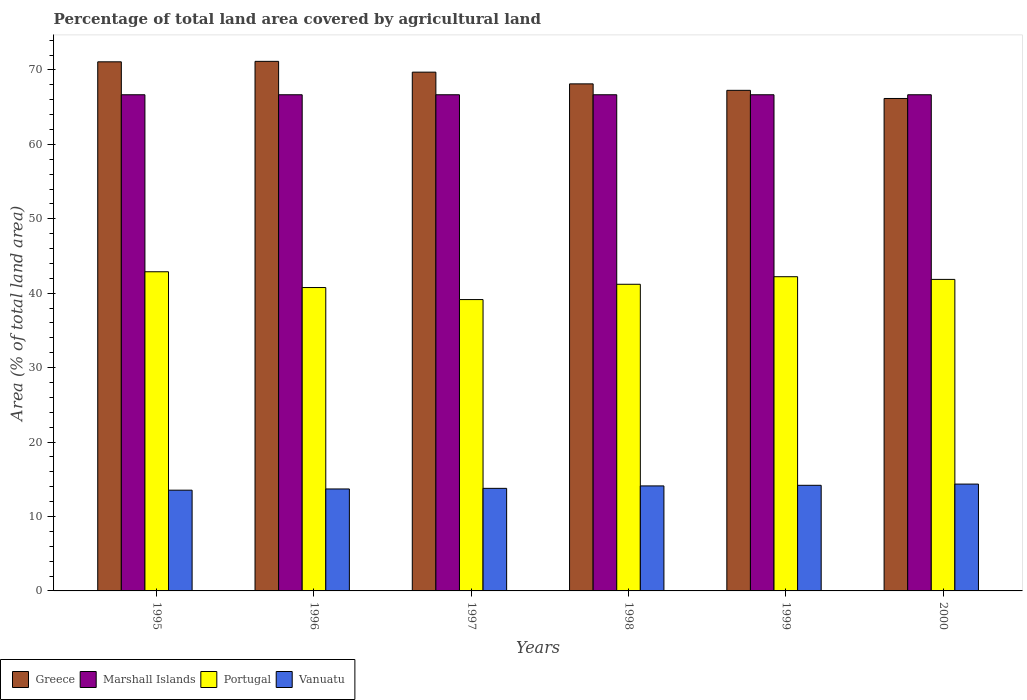Are the number of bars per tick equal to the number of legend labels?
Provide a short and direct response. Yes. Are the number of bars on each tick of the X-axis equal?
Offer a terse response. Yes. How many bars are there on the 3rd tick from the right?
Offer a terse response. 4. In how many cases, is the number of bars for a given year not equal to the number of legend labels?
Offer a very short reply. 0. What is the percentage of agricultural land in Vanuatu in 1998?
Offer a terse response. 14.11. Across all years, what is the maximum percentage of agricultural land in Vanuatu?
Give a very brief answer. 14.36. Across all years, what is the minimum percentage of agricultural land in Vanuatu?
Provide a succinct answer. 13.54. In which year was the percentage of agricultural land in Vanuatu maximum?
Your answer should be compact. 2000. In which year was the percentage of agricultural land in Portugal minimum?
Provide a succinct answer. 1997. What is the total percentage of agricultural land in Portugal in the graph?
Provide a short and direct response. 248.08. What is the difference between the percentage of agricultural land in Portugal in 1998 and that in 1999?
Provide a short and direct response. -1.02. What is the difference between the percentage of agricultural land in Vanuatu in 1998 and the percentage of agricultural land in Greece in 1995?
Provide a succinct answer. -56.98. What is the average percentage of agricultural land in Greece per year?
Keep it short and to the point. 68.92. In the year 1997, what is the difference between the percentage of agricultural land in Portugal and percentage of agricultural land in Vanuatu?
Provide a short and direct response. 25.37. What is the ratio of the percentage of agricultural land in Portugal in 1995 to that in 1997?
Offer a very short reply. 1.1. Is the difference between the percentage of agricultural land in Portugal in 1996 and 1999 greater than the difference between the percentage of agricultural land in Vanuatu in 1996 and 1999?
Ensure brevity in your answer.  No. What is the difference between the highest and the second highest percentage of agricultural land in Marshall Islands?
Your answer should be compact. 0. What is the difference between the highest and the lowest percentage of agricultural land in Marshall Islands?
Your response must be concise. 0. In how many years, is the percentage of agricultural land in Portugal greater than the average percentage of agricultural land in Portugal taken over all years?
Offer a terse response. 3. Is the sum of the percentage of agricultural land in Portugal in 1996 and 1999 greater than the maximum percentage of agricultural land in Vanuatu across all years?
Your answer should be very brief. Yes. What does the 3rd bar from the left in 1995 represents?
Keep it short and to the point. Portugal. What does the 3rd bar from the right in 1998 represents?
Provide a short and direct response. Marshall Islands. Are all the bars in the graph horizontal?
Offer a terse response. No. How many years are there in the graph?
Provide a succinct answer. 6. Are the values on the major ticks of Y-axis written in scientific E-notation?
Your response must be concise. No. Does the graph contain any zero values?
Your answer should be compact. No. Does the graph contain grids?
Give a very brief answer. No. Where does the legend appear in the graph?
Your response must be concise. Bottom left. How are the legend labels stacked?
Keep it short and to the point. Horizontal. What is the title of the graph?
Your response must be concise. Percentage of total land area covered by agricultural land. Does "Haiti" appear as one of the legend labels in the graph?
Provide a short and direct response. No. What is the label or title of the X-axis?
Ensure brevity in your answer.  Years. What is the label or title of the Y-axis?
Your answer should be very brief. Area (% of total land area). What is the Area (% of total land area) in Greece in 1995?
Offer a very short reply. 71.09. What is the Area (% of total land area) of Marshall Islands in 1995?
Keep it short and to the point. 66.67. What is the Area (% of total land area) of Portugal in 1995?
Give a very brief answer. 42.89. What is the Area (% of total land area) in Vanuatu in 1995?
Provide a succinct answer. 13.54. What is the Area (% of total land area) of Greece in 1996?
Make the answer very short. 71.16. What is the Area (% of total land area) of Marshall Islands in 1996?
Provide a short and direct response. 66.67. What is the Area (% of total land area) of Portugal in 1996?
Offer a terse response. 40.77. What is the Area (% of total land area) in Vanuatu in 1996?
Keep it short and to the point. 13.7. What is the Area (% of total land area) in Greece in 1997?
Your answer should be compact. 69.71. What is the Area (% of total land area) in Marshall Islands in 1997?
Provide a succinct answer. 66.67. What is the Area (% of total land area) of Portugal in 1997?
Make the answer very short. 39.15. What is the Area (% of total land area) in Vanuatu in 1997?
Provide a succinct answer. 13.78. What is the Area (% of total land area) of Greece in 1998?
Offer a terse response. 68.13. What is the Area (% of total land area) of Marshall Islands in 1998?
Make the answer very short. 66.67. What is the Area (% of total land area) in Portugal in 1998?
Your response must be concise. 41.2. What is the Area (% of total land area) in Vanuatu in 1998?
Offer a very short reply. 14.11. What is the Area (% of total land area) of Greece in 1999?
Make the answer very short. 67.26. What is the Area (% of total land area) in Marshall Islands in 1999?
Your response must be concise. 66.67. What is the Area (% of total land area) of Portugal in 1999?
Provide a short and direct response. 42.22. What is the Area (% of total land area) of Vanuatu in 1999?
Provide a short and direct response. 14.19. What is the Area (% of total land area) of Greece in 2000?
Your answer should be very brief. 66.17. What is the Area (% of total land area) of Marshall Islands in 2000?
Provide a short and direct response. 66.67. What is the Area (% of total land area) in Portugal in 2000?
Offer a very short reply. 41.86. What is the Area (% of total land area) in Vanuatu in 2000?
Offer a terse response. 14.36. Across all years, what is the maximum Area (% of total land area) of Greece?
Your answer should be compact. 71.16. Across all years, what is the maximum Area (% of total land area) of Marshall Islands?
Offer a terse response. 66.67. Across all years, what is the maximum Area (% of total land area) in Portugal?
Ensure brevity in your answer.  42.89. Across all years, what is the maximum Area (% of total land area) in Vanuatu?
Offer a very short reply. 14.36. Across all years, what is the minimum Area (% of total land area) of Greece?
Make the answer very short. 66.17. Across all years, what is the minimum Area (% of total land area) of Marshall Islands?
Offer a very short reply. 66.67. Across all years, what is the minimum Area (% of total land area) of Portugal?
Make the answer very short. 39.15. Across all years, what is the minimum Area (% of total land area) in Vanuatu?
Your answer should be compact. 13.54. What is the total Area (% of total land area) of Greece in the graph?
Your answer should be very brief. 413.51. What is the total Area (% of total land area) of Portugal in the graph?
Offer a terse response. 248.08. What is the total Area (% of total land area) of Vanuatu in the graph?
Provide a short and direct response. 83.68. What is the difference between the Area (% of total land area) of Greece in 1995 and that in 1996?
Ensure brevity in your answer.  -0.06. What is the difference between the Area (% of total land area) in Marshall Islands in 1995 and that in 1996?
Give a very brief answer. 0. What is the difference between the Area (% of total land area) of Portugal in 1995 and that in 1996?
Give a very brief answer. 2.12. What is the difference between the Area (% of total land area) of Vanuatu in 1995 and that in 1996?
Provide a short and direct response. -0.16. What is the difference between the Area (% of total land area) of Greece in 1995 and that in 1997?
Give a very brief answer. 1.39. What is the difference between the Area (% of total land area) in Portugal in 1995 and that in 1997?
Offer a terse response. 3.74. What is the difference between the Area (% of total land area) in Vanuatu in 1995 and that in 1997?
Keep it short and to the point. -0.25. What is the difference between the Area (% of total land area) of Greece in 1995 and that in 1998?
Your answer should be compact. 2.96. What is the difference between the Area (% of total land area) of Portugal in 1995 and that in 1998?
Offer a very short reply. 1.68. What is the difference between the Area (% of total land area) of Vanuatu in 1995 and that in 1998?
Make the answer very short. -0.57. What is the difference between the Area (% of total land area) in Greece in 1995 and that in 1999?
Provide a short and direct response. 3.83. What is the difference between the Area (% of total land area) in Vanuatu in 1995 and that in 1999?
Give a very brief answer. -0.66. What is the difference between the Area (% of total land area) of Greece in 1995 and that in 2000?
Ensure brevity in your answer.  4.93. What is the difference between the Area (% of total land area) in Portugal in 1995 and that in 2000?
Keep it short and to the point. 1.03. What is the difference between the Area (% of total land area) in Vanuatu in 1995 and that in 2000?
Ensure brevity in your answer.  -0.82. What is the difference between the Area (% of total land area) of Greece in 1996 and that in 1997?
Offer a very short reply. 1.45. What is the difference between the Area (% of total land area) in Portugal in 1996 and that in 1997?
Give a very brief answer. 1.62. What is the difference between the Area (% of total land area) in Vanuatu in 1996 and that in 1997?
Ensure brevity in your answer.  -0.08. What is the difference between the Area (% of total land area) in Greece in 1996 and that in 1998?
Offer a terse response. 3.03. What is the difference between the Area (% of total land area) in Marshall Islands in 1996 and that in 1998?
Offer a terse response. 0. What is the difference between the Area (% of total land area) in Portugal in 1996 and that in 1998?
Your answer should be very brief. -0.44. What is the difference between the Area (% of total land area) in Vanuatu in 1996 and that in 1998?
Offer a very short reply. -0.41. What is the difference between the Area (% of total land area) in Greece in 1996 and that in 1999?
Offer a very short reply. 3.89. What is the difference between the Area (% of total land area) of Marshall Islands in 1996 and that in 1999?
Your answer should be very brief. 0. What is the difference between the Area (% of total land area) in Portugal in 1996 and that in 1999?
Offer a very short reply. -1.45. What is the difference between the Area (% of total land area) of Vanuatu in 1996 and that in 1999?
Provide a succinct answer. -0.49. What is the difference between the Area (% of total land area) in Greece in 1996 and that in 2000?
Provide a succinct answer. 4.99. What is the difference between the Area (% of total land area) of Marshall Islands in 1996 and that in 2000?
Your answer should be very brief. 0. What is the difference between the Area (% of total land area) in Portugal in 1996 and that in 2000?
Provide a succinct answer. -1.09. What is the difference between the Area (% of total land area) of Vanuatu in 1996 and that in 2000?
Provide a succinct answer. -0.66. What is the difference between the Area (% of total land area) in Greece in 1997 and that in 1998?
Provide a succinct answer. 1.57. What is the difference between the Area (% of total land area) in Portugal in 1997 and that in 1998?
Your answer should be compact. -2.05. What is the difference between the Area (% of total land area) of Vanuatu in 1997 and that in 1998?
Ensure brevity in your answer.  -0.33. What is the difference between the Area (% of total land area) of Greece in 1997 and that in 1999?
Provide a short and direct response. 2.44. What is the difference between the Area (% of total land area) in Marshall Islands in 1997 and that in 1999?
Your answer should be compact. 0. What is the difference between the Area (% of total land area) of Portugal in 1997 and that in 1999?
Your answer should be compact. -3.07. What is the difference between the Area (% of total land area) of Vanuatu in 1997 and that in 1999?
Offer a terse response. -0.41. What is the difference between the Area (% of total land area) in Greece in 1997 and that in 2000?
Give a very brief answer. 3.54. What is the difference between the Area (% of total land area) of Portugal in 1997 and that in 2000?
Provide a succinct answer. -2.71. What is the difference between the Area (% of total land area) in Vanuatu in 1997 and that in 2000?
Your answer should be very brief. -0.57. What is the difference between the Area (% of total land area) of Greece in 1998 and that in 1999?
Make the answer very short. 0.87. What is the difference between the Area (% of total land area) in Portugal in 1998 and that in 1999?
Ensure brevity in your answer.  -1.02. What is the difference between the Area (% of total land area) in Vanuatu in 1998 and that in 1999?
Offer a terse response. -0.08. What is the difference between the Area (% of total land area) of Greece in 1998 and that in 2000?
Ensure brevity in your answer.  1.96. What is the difference between the Area (% of total land area) of Portugal in 1998 and that in 2000?
Offer a very short reply. -0.66. What is the difference between the Area (% of total land area) of Vanuatu in 1998 and that in 2000?
Ensure brevity in your answer.  -0.25. What is the difference between the Area (% of total land area) of Greece in 1999 and that in 2000?
Ensure brevity in your answer.  1.09. What is the difference between the Area (% of total land area) of Portugal in 1999 and that in 2000?
Your answer should be very brief. 0.36. What is the difference between the Area (% of total land area) in Vanuatu in 1999 and that in 2000?
Your answer should be compact. -0.16. What is the difference between the Area (% of total land area) of Greece in 1995 and the Area (% of total land area) of Marshall Islands in 1996?
Offer a terse response. 4.43. What is the difference between the Area (% of total land area) of Greece in 1995 and the Area (% of total land area) of Portugal in 1996?
Make the answer very short. 30.33. What is the difference between the Area (% of total land area) of Greece in 1995 and the Area (% of total land area) of Vanuatu in 1996?
Your answer should be compact. 57.39. What is the difference between the Area (% of total land area) of Marshall Islands in 1995 and the Area (% of total land area) of Portugal in 1996?
Ensure brevity in your answer.  25.9. What is the difference between the Area (% of total land area) of Marshall Islands in 1995 and the Area (% of total land area) of Vanuatu in 1996?
Keep it short and to the point. 52.97. What is the difference between the Area (% of total land area) of Portugal in 1995 and the Area (% of total land area) of Vanuatu in 1996?
Keep it short and to the point. 29.19. What is the difference between the Area (% of total land area) of Greece in 1995 and the Area (% of total land area) of Marshall Islands in 1997?
Offer a very short reply. 4.43. What is the difference between the Area (% of total land area) of Greece in 1995 and the Area (% of total land area) of Portugal in 1997?
Keep it short and to the point. 31.95. What is the difference between the Area (% of total land area) of Greece in 1995 and the Area (% of total land area) of Vanuatu in 1997?
Offer a very short reply. 57.31. What is the difference between the Area (% of total land area) in Marshall Islands in 1995 and the Area (% of total land area) in Portugal in 1997?
Provide a short and direct response. 27.52. What is the difference between the Area (% of total land area) of Marshall Islands in 1995 and the Area (% of total land area) of Vanuatu in 1997?
Provide a succinct answer. 52.88. What is the difference between the Area (% of total land area) of Portugal in 1995 and the Area (% of total land area) of Vanuatu in 1997?
Provide a short and direct response. 29.1. What is the difference between the Area (% of total land area) of Greece in 1995 and the Area (% of total land area) of Marshall Islands in 1998?
Provide a short and direct response. 4.43. What is the difference between the Area (% of total land area) of Greece in 1995 and the Area (% of total land area) of Portugal in 1998?
Offer a very short reply. 29.89. What is the difference between the Area (% of total land area) of Greece in 1995 and the Area (% of total land area) of Vanuatu in 1998?
Offer a terse response. 56.98. What is the difference between the Area (% of total land area) in Marshall Islands in 1995 and the Area (% of total land area) in Portugal in 1998?
Keep it short and to the point. 25.46. What is the difference between the Area (% of total land area) of Marshall Islands in 1995 and the Area (% of total land area) of Vanuatu in 1998?
Keep it short and to the point. 52.56. What is the difference between the Area (% of total land area) in Portugal in 1995 and the Area (% of total land area) in Vanuatu in 1998?
Your answer should be compact. 28.78. What is the difference between the Area (% of total land area) of Greece in 1995 and the Area (% of total land area) of Marshall Islands in 1999?
Ensure brevity in your answer.  4.43. What is the difference between the Area (% of total land area) in Greece in 1995 and the Area (% of total land area) in Portugal in 1999?
Provide a short and direct response. 28.88. What is the difference between the Area (% of total land area) of Greece in 1995 and the Area (% of total land area) of Vanuatu in 1999?
Your response must be concise. 56.9. What is the difference between the Area (% of total land area) of Marshall Islands in 1995 and the Area (% of total land area) of Portugal in 1999?
Ensure brevity in your answer.  24.45. What is the difference between the Area (% of total land area) of Marshall Islands in 1995 and the Area (% of total land area) of Vanuatu in 1999?
Keep it short and to the point. 52.47. What is the difference between the Area (% of total land area) in Portugal in 1995 and the Area (% of total land area) in Vanuatu in 1999?
Offer a very short reply. 28.69. What is the difference between the Area (% of total land area) of Greece in 1995 and the Area (% of total land area) of Marshall Islands in 2000?
Your answer should be compact. 4.43. What is the difference between the Area (% of total land area) in Greece in 1995 and the Area (% of total land area) in Portugal in 2000?
Offer a very short reply. 29.24. What is the difference between the Area (% of total land area) of Greece in 1995 and the Area (% of total land area) of Vanuatu in 2000?
Your answer should be very brief. 56.74. What is the difference between the Area (% of total land area) in Marshall Islands in 1995 and the Area (% of total land area) in Portugal in 2000?
Ensure brevity in your answer.  24.81. What is the difference between the Area (% of total land area) in Marshall Islands in 1995 and the Area (% of total land area) in Vanuatu in 2000?
Keep it short and to the point. 52.31. What is the difference between the Area (% of total land area) of Portugal in 1995 and the Area (% of total land area) of Vanuatu in 2000?
Ensure brevity in your answer.  28.53. What is the difference between the Area (% of total land area) in Greece in 1996 and the Area (% of total land area) in Marshall Islands in 1997?
Offer a very short reply. 4.49. What is the difference between the Area (% of total land area) in Greece in 1996 and the Area (% of total land area) in Portugal in 1997?
Offer a terse response. 32.01. What is the difference between the Area (% of total land area) in Greece in 1996 and the Area (% of total land area) in Vanuatu in 1997?
Ensure brevity in your answer.  57.37. What is the difference between the Area (% of total land area) of Marshall Islands in 1996 and the Area (% of total land area) of Portugal in 1997?
Your response must be concise. 27.52. What is the difference between the Area (% of total land area) of Marshall Islands in 1996 and the Area (% of total land area) of Vanuatu in 1997?
Keep it short and to the point. 52.88. What is the difference between the Area (% of total land area) of Portugal in 1996 and the Area (% of total land area) of Vanuatu in 1997?
Keep it short and to the point. 26.98. What is the difference between the Area (% of total land area) in Greece in 1996 and the Area (% of total land area) in Marshall Islands in 1998?
Make the answer very short. 4.49. What is the difference between the Area (% of total land area) in Greece in 1996 and the Area (% of total land area) in Portugal in 1998?
Give a very brief answer. 29.95. What is the difference between the Area (% of total land area) of Greece in 1996 and the Area (% of total land area) of Vanuatu in 1998?
Ensure brevity in your answer.  57.05. What is the difference between the Area (% of total land area) in Marshall Islands in 1996 and the Area (% of total land area) in Portugal in 1998?
Give a very brief answer. 25.46. What is the difference between the Area (% of total land area) of Marshall Islands in 1996 and the Area (% of total land area) of Vanuatu in 1998?
Offer a terse response. 52.56. What is the difference between the Area (% of total land area) in Portugal in 1996 and the Area (% of total land area) in Vanuatu in 1998?
Offer a terse response. 26.66. What is the difference between the Area (% of total land area) of Greece in 1996 and the Area (% of total land area) of Marshall Islands in 1999?
Offer a terse response. 4.49. What is the difference between the Area (% of total land area) of Greece in 1996 and the Area (% of total land area) of Portugal in 1999?
Your answer should be very brief. 28.94. What is the difference between the Area (% of total land area) in Greece in 1996 and the Area (% of total land area) in Vanuatu in 1999?
Ensure brevity in your answer.  56.96. What is the difference between the Area (% of total land area) in Marshall Islands in 1996 and the Area (% of total land area) in Portugal in 1999?
Make the answer very short. 24.45. What is the difference between the Area (% of total land area) of Marshall Islands in 1996 and the Area (% of total land area) of Vanuatu in 1999?
Your answer should be compact. 52.47. What is the difference between the Area (% of total land area) in Portugal in 1996 and the Area (% of total land area) in Vanuatu in 1999?
Offer a terse response. 26.57. What is the difference between the Area (% of total land area) of Greece in 1996 and the Area (% of total land area) of Marshall Islands in 2000?
Your response must be concise. 4.49. What is the difference between the Area (% of total land area) of Greece in 1996 and the Area (% of total land area) of Portugal in 2000?
Your response must be concise. 29.3. What is the difference between the Area (% of total land area) in Greece in 1996 and the Area (% of total land area) in Vanuatu in 2000?
Make the answer very short. 56.8. What is the difference between the Area (% of total land area) in Marshall Islands in 1996 and the Area (% of total land area) in Portugal in 2000?
Offer a terse response. 24.81. What is the difference between the Area (% of total land area) of Marshall Islands in 1996 and the Area (% of total land area) of Vanuatu in 2000?
Keep it short and to the point. 52.31. What is the difference between the Area (% of total land area) in Portugal in 1996 and the Area (% of total land area) in Vanuatu in 2000?
Ensure brevity in your answer.  26.41. What is the difference between the Area (% of total land area) in Greece in 1997 and the Area (% of total land area) in Marshall Islands in 1998?
Offer a terse response. 3.04. What is the difference between the Area (% of total land area) of Greece in 1997 and the Area (% of total land area) of Portugal in 1998?
Offer a terse response. 28.5. What is the difference between the Area (% of total land area) of Greece in 1997 and the Area (% of total land area) of Vanuatu in 1998?
Make the answer very short. 55.6. What is the difference between the Area (% of total land area) of Marshall Islands in 1997 and the Area (% of total land area) of Portugal in 1998?
Make the answer very short. 25.46. What is the difference between the Area (% of total land area) of Marshall Islands in 1997 and the Area (% of total land area) of Vanuatu in 1998?
Offer a terse response. 52.56. What is the difference between the Area (% of total land area) in Portugal in 1997 and the Area (% of total land area) in Vanuatu in 1998?
Your response must be concise. 25.04. What is the difference between the Area (% of total land area) in Greece in 1997 and the Area (% of total land area) in Marshall Islands in 1999?
Offer a very short reply. 3.04. What is the difference between the Area (% of total land area) in Greece in 1997 and the Area (% of total land area) in Portugal in 1999?
Offer a very short reply. 27.49. What is the difference between the Area (% of total land area) of Greece in 1997 and the Area (% of total land area) of Vanuatu in 1999?
Offer a terse response. 55.51. What is the difference between the Area (% of total land area) of Marshall Islands in 1997 and the Area (% of total land area) of Portugal in 1999?
Ensure brevity in your answer.  24.45. What is the difference between the Area (% of total land area) in Marshall Islands in 1997 and the Area (% of total land area) in Vanuatu in 1999?
Make the answer very short. 52.47. What is the difference between the Area (% of total land area) in Portugal in 1997 and the Area (% of total land area) in Vanuatu in 1999?
Give a very brief answer. 24.96. What is the difference between the Area (% of total land area) in Greece in 1997 and the Area (% of total land area) in Marshall Islands in 2000?
Ensure brevity in your answer.  3.04. What is the difference between the Area (% of total land area) of Greece in 1997 and the Area (% of total land area) of Portugal in 2000?
Your answer should be very brief. 27.85. What is the difference between the Area (% of total land area) in Greece in 1997 and the Area (% of total land area) in Vanuatu in 2000?
Offer a very short reply. 55.35. What is the difference between the Area (% of total land area) of Marshall Islands in 1997 and the Area (% of total land area) of Portugal in 2000?
Offer a very short reply. 24.81. What is the difference between the Area (% of total land area) in Marshall Islands in 1997 and the Area (% of total land area) in Vanuatu in 2000?
Offer a very short reply. 52.31. What is the difference between the Area (% of total land area) in Portugal in 1997 and the Area (% of total land area) in Vanuatu in 2000?
Offer a very short reply. 24.79. What is the difference between the Area (% of total land area) of Greece in 1998 and the Area (% of total land area) of Marshall Islands in 1999?
Your answer should be compact. 1.46. What is the difference between the Area (% of total land area) in Greece in 1998 and the Area (% of total land area) in Portugal in 1999?
Provide a short and direct response. 25.91. What is the difference between the Area (% of total land area) in Greece in 1998 and the Area (% of total land area) in Vanuatu in 1999?
Your answer should be very brief. 53.94. What is the difference between the Area (% of total land area) in Marshall Islands in 1998 and the Area (% of total land area) in Portugal in 1999?
Give a very brief answer. 24.45. What is the difference between the Area (% of total land area) in Marshall Islands in 1998 and the Area (% of total land area) in Vanuatu in 1999?
Ensure brevity in your answer.  52.47. What is the difference between the Area (% of total land area) in Portugal in 1998 and the Area (% of total land area) in Vanuatu in 1999?
Keep it short and to the point. 27.01. What is the difference between the Area (% of total land area) in Greece in 1998 and the Area (% of total land area) in Marshall Islands in 2000?
Offer a terse response. 1.46. What is the difference between the Area (% of total land area) of Greece in 1998 and the Area (% of total land area) of Portugal in 2000?
Your answer should be compact. 26.27. What is the difference between the Area (% of total land area) of Greece in 1998 and the Area (% of total land area) of Vanuatu in 2000?
Keep it short and to the point. 53.77. What is the difference between the Area (% of total land area) of Marshall Islands in 1998 and the Area (% of total land area) of Portugal in 2000?
Keep it short and to the point. 24.81. What is the difference between the Area (% of total land area) of Marshall Islands in 1998 and the Area (% of total land area) of Vanuatu in 2000?
Keep it short and to the point. 52.31. What is the difference between the Area (% of total land area) in Portugal in 1998 and the Area (% of total land area) in Vanuatu in 2000?
Make the answer very short. 26.85. What is the difference between the Area (% of total land area) of Greece in 1999 and the Area (% of total land area) of Marshall Islands in 2000?
Offer a very short reply. 0.59. What is the difference between the Area (% of total land area) of Greece in 1999 and the Area (% of total land area) of Portugal in 2000?
Your answer should be very brief. 25.4. What is the difference between the Area (% of total land area) in Greece in 1999 and the Area (% of total land area) in Vanuatu in 2000?
Ensure brevity in your answer.  52.91. What is the difference between the Area (% of total land area) in Marshall Islands in 1999 and the Area (% of total land area) in Portugal in 2000?
Provide a succinct answer. 24.81. What is the difference between the Area (% of total land area) of Marshall Islands in 1999 and the Area (% of total land area) of Vanuatu in 2000?
Offer a terse response. 52.31. What is the difference between the Area (% of total land area) of Portugal in 1999 and the Area (% of total land area) of Vanuatu in 2000?
Provide a short and direct response. 27.86. What is the average Area (% of total land area) of Greece per year?
Provide a short and direct response. 68.92. What is the average Area (% of total land area) of Marshall Islands per year?
Your response must be concise. 66.67. What is the average Area (% of total land area) of Portugal per year?
Give a very brief answer. 41.35. What is the average Area (% of total land area) of Vanuatu per year?
Your response must be concise. 13.95. In the year 1995, what is the difference between the Area (% of total land area) in Greece and Area (% of total land area) in Marshall Islands?
Make the answer very short. 4.43. In the year 1995, what is the difference between the Area (% of total land area) of Greece and Area (% of total land area) of Portugal?
Provide a short and direct response. 28.21. In the year 1995, what is the difference between the Area (% of total land area) of Greece and Area (% of total land area) of Vanuatu?
Make the answer very short. 57.56. In the year 1995, what is the difference between the Area (% of total land area) of Marshall Islands and Area (% of total land area) of Portugal?
Provide a short and direct response. 23.78. In the year 1995, what is the difference between the Area (% of total land area) of Marshall Islands and Area (% of total land area) of Vanuatu?
Keep it short and to the point. 53.13. In the year 1995, what is the difference between the Area (% of total land area) in Portugal and Area (% of total land area) in Vanuatu?
Give a very brief answer. 29.35. In the year 1996, what is the difference between the Area (% of total land area) of Greece and Area (% of total land area) of Marshall Islands?
Your response must be concise. 4.49. In the year 1996, what is the difference between the Area (% of total land area) of Greece and Area (% of total land area) of Portugal?
Make the answer very short. 30.39. In the year 1996, what is the difference between the Area (% of total land area) in Greece and Area (% of total land area) in Vanuatu?
Your response must be concise. 57.46. In the year 1996, what is the difference between the Area (% of total land area) of Marshall Islands and Area (% of total land area) of Portugal?
Offer a terse response. 25.9. In the year 1996, what is the difference between the Area (% of total land area) of Marshall Islands and Area (% of total land area) of Vanuatu?
Ensure brevity in your answer.  52.97. In the year 1996, what is the difference between the Area (% of total land area) of Portugal and Area (% of total land area) of Vanuatu?
Make the answer very short. 27.07. In the year 1997, what is the difference between the Area (% of total land area) in Greece and Area (% of total land area) in Marshall Islands?
Give a very brief answer. 3.04. In the year 1997, what is the difference between the Area (% of total land area) of Greece and Area (% of total land area) of Portugal?
Make the answer very short. 30.56. In the year 1997, what is the difference between the Area (% of total land area) in Greece and Area (% of total land area) in Vanuatu?
Offer a very short reply. 55.92. In the year 1997, what is the difference between the Area (% of total land area) in Marshall Islands and Area (% of total land area) in Portugal?
Your answer should be very brief. 27.52. In the year 1997, what is the difference between the Area (% of total land area) in Marshall Islands and Area (% of total land area) in Vanuatu?
Provide a succinct answer. 52.88. In the year 1997, what is the difference between the Area (% of total land area) of Portugal and Area (% of total land area) of Vanuatu?
Provide a succinct answer. 25.37. In the year 1998, what is the difference between the Area (% of total land area) of Greece and Area (% of total land area) of Marshall Islands?
Offer a very short reply. 1.46. In the year 1998, what is the difference between the Area (% of total land area) in Greece and Area (% of total land area) in Portugal?
Give a very brief answer. 26.93. In the year 1998, what is the difference between the Area (% of total land area) of Greece and Area (% of total land area) of Vanuatu?
Provide a succinct answer. 54.02. In the year 1998, what is the difference between the Area (% of total land area) of Marshall Islands and Area (% of total land area) of Portugal?
Your answer should be very brief. 25.46. In the year 1998, what is the difference between the Area (% of total land area) in Marshall Islands and Area (% of total land area) in Vanuatu?
Your answer should be compact. 52.56. In the year 1998, what is the difference between the Area (% of total land area) in Portugal and Area (% of total land area) in Vanuatu?
Offer a terse response. 27.09. In the year 1999, what is the difference between the Area (% of total land area) in Greece and Area (% of total land area) in Marshall Islands?
Your answer should be compact. 0.59. In the year 1999, what is the difference between the Area (% of total land area) in Greece and Area (% of total land area) in Portugal?
Make the answer very short. 25.04. In the year 1999, what is the difference between the Area (% of total land area) of Greece and Area (% of total land area) of Vanuatu?
Your response must be concise. 53.07. In the year 1999, what is the difference between the Area (% of total land area) of Marshall Islands and Area (% of total land area) of Portugal?
Make the answer very short. 24.45. In the year 1999, what is the difference between the Area (% of total land area) in Marshall Islands and Area (% of total land area) in Vanuatu?
Your answer should be compact. 52.47. In the year 1999, what is the difference between the Area (% of total land area) of Portugal and Area (% of total land area) of Vanuatu?
Your answer should be compact. 28.03. In the year 2000, what is the difference between the Area (% of total land area) of Greece and Area (% of total land area) of Marshall Islands?
Your answer should be very brief. -0.5. In the year 2000, what is the difference between the Area (% of total land area) of Greece and Area (% of total land area) of Portugal?
Your response must be concise. 24.31. In the year 2000, what is the difference between the Area (% of total land area) of Greece and Area (% of total land area) of Vanuatu?
Give a very brief answer. 51.81. In the year 2000, what is the difference between the Area (% of total land area) in Marshall Islands and Area (% of total land area) in Portugal?
Keep it short and to the point. 24.81. In the year 2000, what is the difference between the Area (% of total land area) of Marshall Islands and Area (% of total land area) of Vanuatu?
Offer a terse response. 52.31. In the year 2000, what is the difference between the Area (% of total land area) in Portugal and Area (% of total land area) in Vanuatu?
Your answer should be compact. 27.5. What is the ratio of the Area (% of total land area) in Greece in 1995 to that in 1996?
Your answer should be very brief. 1. What is the ratio of the Area (% of total land area) in Portugal in 1995 to that in 1996?
Give a very brief answer. 1.05. What is the ratio of the Area (% of total land area) of Vanuatu in 1995 to that in 1996?
Provide a short and direct response. 0.99. What is the ratio of the Area (% of total land area) in Greece in 1995 to that in 1997?
Your answer should be very brief. 1.02. What is the ratio of the Area (% of total land area) in Marshall Islands in 1995 to that in 1997?
Keep it short and to the point. 1. What is the ratio of the Area (% of total land area) in Portugal in 1995 to that in 1997?
Your answer should be very brief. 1.1. What is the ratio of the Area (% of total land area) in Vanuatu in 1995 to that in 1997?
Make the answer very short. 0.98. What is the ratio of the Area (% of total land area) in Greece in 1995 to that in 1998?
Keep it short and to the point. 1.04. What is the ratio of the Area (% of total land area) in Portugal in 1995 to that in 1998?
Make the answer very short. 1.04. What is the ratio of the Area (% of total land area) of Vanuatu in 1995 to that in 1998?
Your response must be concise. 0.96. What is the ratio of the Area (% of total land area) in Greece in 1995 to that in 1999?
Keep it short and to the point. 1.06. What is the ratio of the Area (% of total land area) of Marshall Islands in 1995 to that in 1999?
Provide a short and direct response. 1. What is the ratio of the Area (% of total land area) in Portugal in 1995 to that in 1999?
Your answer should be compact. 1.02. What is the ratio of the Area (% of total land area) of Vanuatu in 1995 to that in 1999?
Offer a very short reply. 0.95. What is the ratio of the Area (% of total land area) of Greece in 1995 to that in 2000?
Your answer should be very brief. 1.07. What is the ratio of the Area (% of total land area) of Portugal in 1995 to that in 2000?
Your answer should be very brief. 1.02. What is the ratio of the Area (% of total land area) in Vanuatu in 1995 to that in 2000?
Your response must be concise. 0.94. What is the ratio of the Area (% of total land area) of Greece in 1996 to that in 1997?
Ensure brevity in your answer.  1.02. What is the ratio of the Area (% of total land area) in Portugal in 1996 to that in 1997?
Give a very brief answer. 1.04. What is the ratio of the Area (% of total land area) in Greece in 1996 to that in 1998?
Your response must be concise. 1.04. What is the ratio of the Area (% of total land area) in Marshall Islands in 1996 to that in 1998?
Offer a terse response. 1. What is the ratio of the Area (% of total land area) in Portugal in 1996 to that in 1998?
Give a very brief answer. 0.99. What is the ratio of the Area (% of total land area) of Vanuatu in 1996 to that in 1998?
Your response must be concise. 0.97. What is the ratio of the Area (% of total land area) in Greece in 1996 to that in 1999?
Your answer should be compact. 1.06. What is the ratio of the Area (% of total land area) in Portugal in 1996 to that in 1999?
Your answer should be very brief. 0.97. What is the ratio of the Area (% of total land area) in Vanuatu in 1996 to that in 1999?
Provide a short and direct response. 0.97. What is the ratio of the Area (% of total land area) of Greece in 1996 to that in 2000?
Provide a short and direct response. 1.08. What is the ratio of the Area (% of total land area) of Marshall Islands in 1996 to that in 2000?
Your answer should be very brief. 1. What is the ratio of the Area (% of total land area) in Portugal in 1996 to that in 2000?
Make the answer very short. 0.97. What is the ratio of the Area (% of total land area) in Vanuatu in 1996 to that in 2000?
Offer a terse response. 0.95. What is the ratio of the Area (% of total land area) of Greece in 1997 to that in 1998?
Offer a very short reply. 1.02. What is the ratio of the Area (% of total land area) in Marshall Islands in 1997 to that in 1998?
Keep it short and to the point. 1. What is the ratio of the Area (% of total land area) in Portugal in 1997 to that in 1998?
Offer a very short reply. 0.95. What is the ratio of the Area (% of total land area) in Vanuatu in 1997 to that in 1998?
Give a very brief answer. 0.98. What is the ratio of the Area (% of total land area) of Greece in 1997 to that in 1999?
Give a very brief answer. 1.04. What is the ratio of the Area (% of total land area) of Portugal in 1997 to that in 1999?
Your answer should be compact. 0.93. What is the ratio of the Area (% of total land area) of Vanuatu in 1997 to that in 1999?
Give a very brief answer. 0.97. What is the ratio of the Area (% of total land area) of Greece in 1997 to that in 2000?
Ensure brevity in your answer.  1.05. What is the ratio of the Area (% of total land area) of Portugal in 1997 to that in 2000?
Your response must be concise. 0.94. What is the ratio of the Area (% of total land area) in Greece in 1998 to that in 1999?
Offer a terse response. 1.01. What is the ratio of the Area (% of total land area) of Portugal in 1998 to that in 1999?
Offer a very short reply. 0.98. What is the ratio of the Area (% of total land area) in Greece in 1998 to that in 2000?
Provide a succinct answer. 1.03. What is the ratio of the Area (% of total land area) in Marshall Islands in 1998 to that in 2000?
Your answer should be compact. 1. What is the ratio of the Area (% of total land area) in Portugal in 1998 to that in 2000?
Make the answer very short. 0.98. What is the ratio of the Area (% of total land area) of Vanuatu in 1998 to that in 2000?
Keep it short and to the point. 0.98. What is the ratio of the Area (% of total land area) in Greece in 1999 to that in 2000?
Offer a very short reply. 1.02. What is the ratio of the Area (% of total land area) in Marshall Islands in 1999 to that in 2000?
Your answer should be very brief. 1. What is the ratio of the Area (% of total land area) in Portugal in 1999 to that in 2000?
Your answer should be very brief. 1.01. What is the difference between the highest and the second highest Area (% of total land area) in Greece?
Your response must be concise. 0.06. What is the difference between the highest and the second highest Area (% of total land area) of Marshall Islands?
Give a very brief answer. 0. What is the difference between the highest and the second highest Area (% of total land area) of Vanuatu?
Offer a terse response. 0.16. What is the difference between the highest and the lowest Area (% of total land area) in Greece?
Provide a short and direct response. 4.99. What is the difference between the highest and the lowest Area (% of total land area) in Portugal?
Make the answer very short. 3.74. What is the difference between the highest and the lowest Area (% of total land area) of Vanuatu?
Provide a succinct answer. 0.82. 